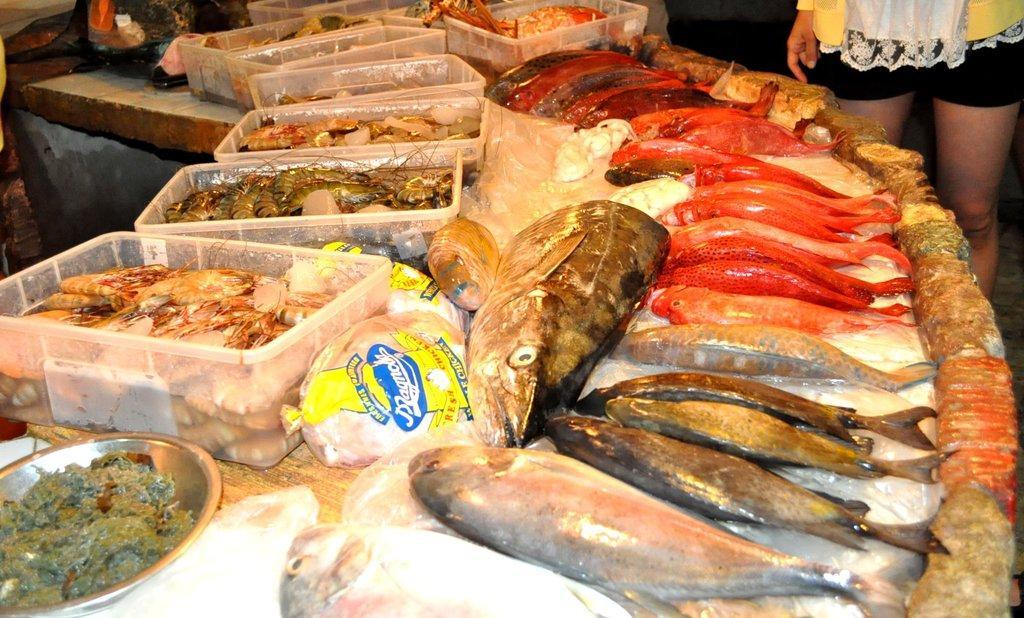Could you give a brief overview of what you see in this image? In the foreground of the picture there are marine animals like fish, prawns and there are covers, boxes and a plate. On the right there is a person. 